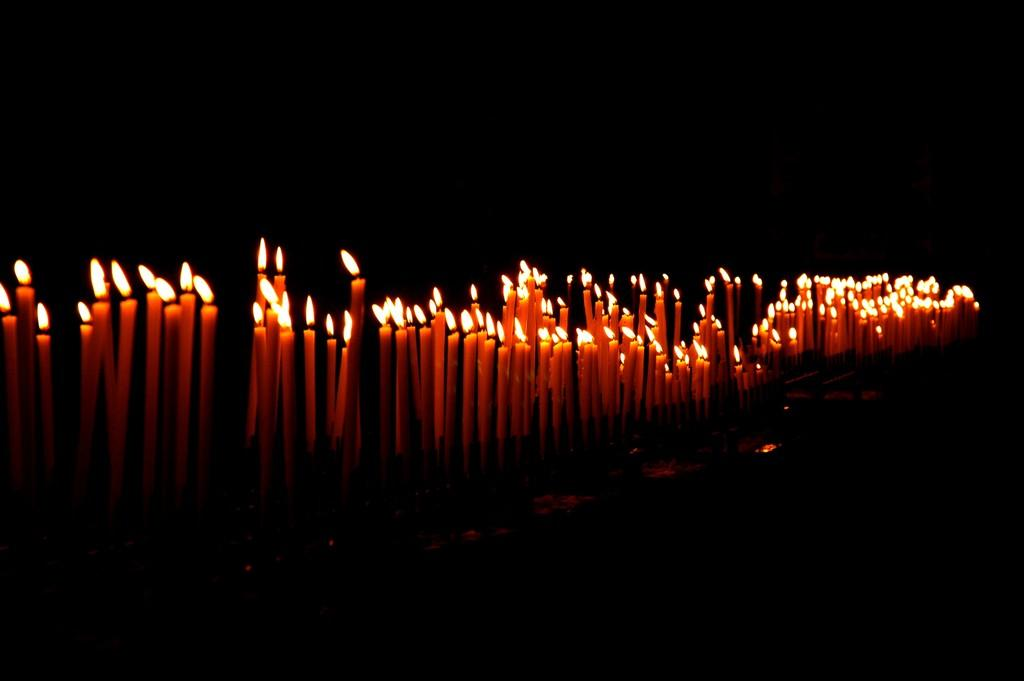What objects can be seen in the image? There are candles in the image. What can be observed about the lighting in the image? The background of the image is dark. What type of insurance policy is being discussed in the image? There is no mention of insurance or any discussion in the image; it only features candles and a dark background. 